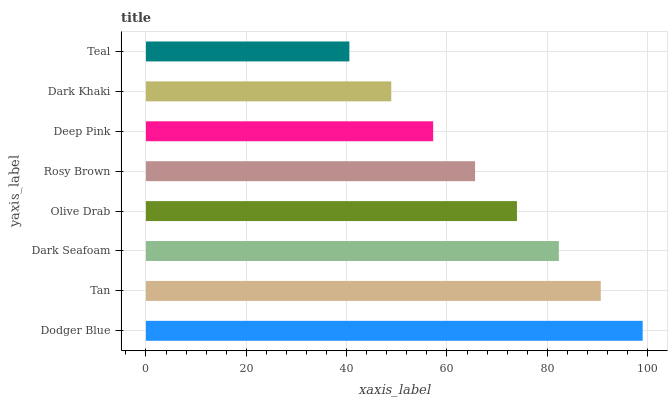Is Teal the minimum?
Answer yes or no. Yes. Is Dodger Blue the maximum?
Answer yes or no. Yes. Is Tan the minimum?
Answer yes or no. No. Is Tan the maximum?
Answer yes or no. No. Is Dodger Blue greater than Tan?
Answer yes or no. Yes. Is Tan less than Dodger Blue?
Answer yes or no. Yes. Is Tan greater than Dodger Blue?
Answer yes or no. No. Is Dodger Blue less than Tan?
Answer yes or no. No. Is Olive Drab the high median?
Answer yes or no. Yes. Is Rosy Brown the low median?
Answer yes or no. Yes. Is Deep Pink the high median?
Answer yes or no. No. Is Tan the low median?
Answer yes or no. No. 